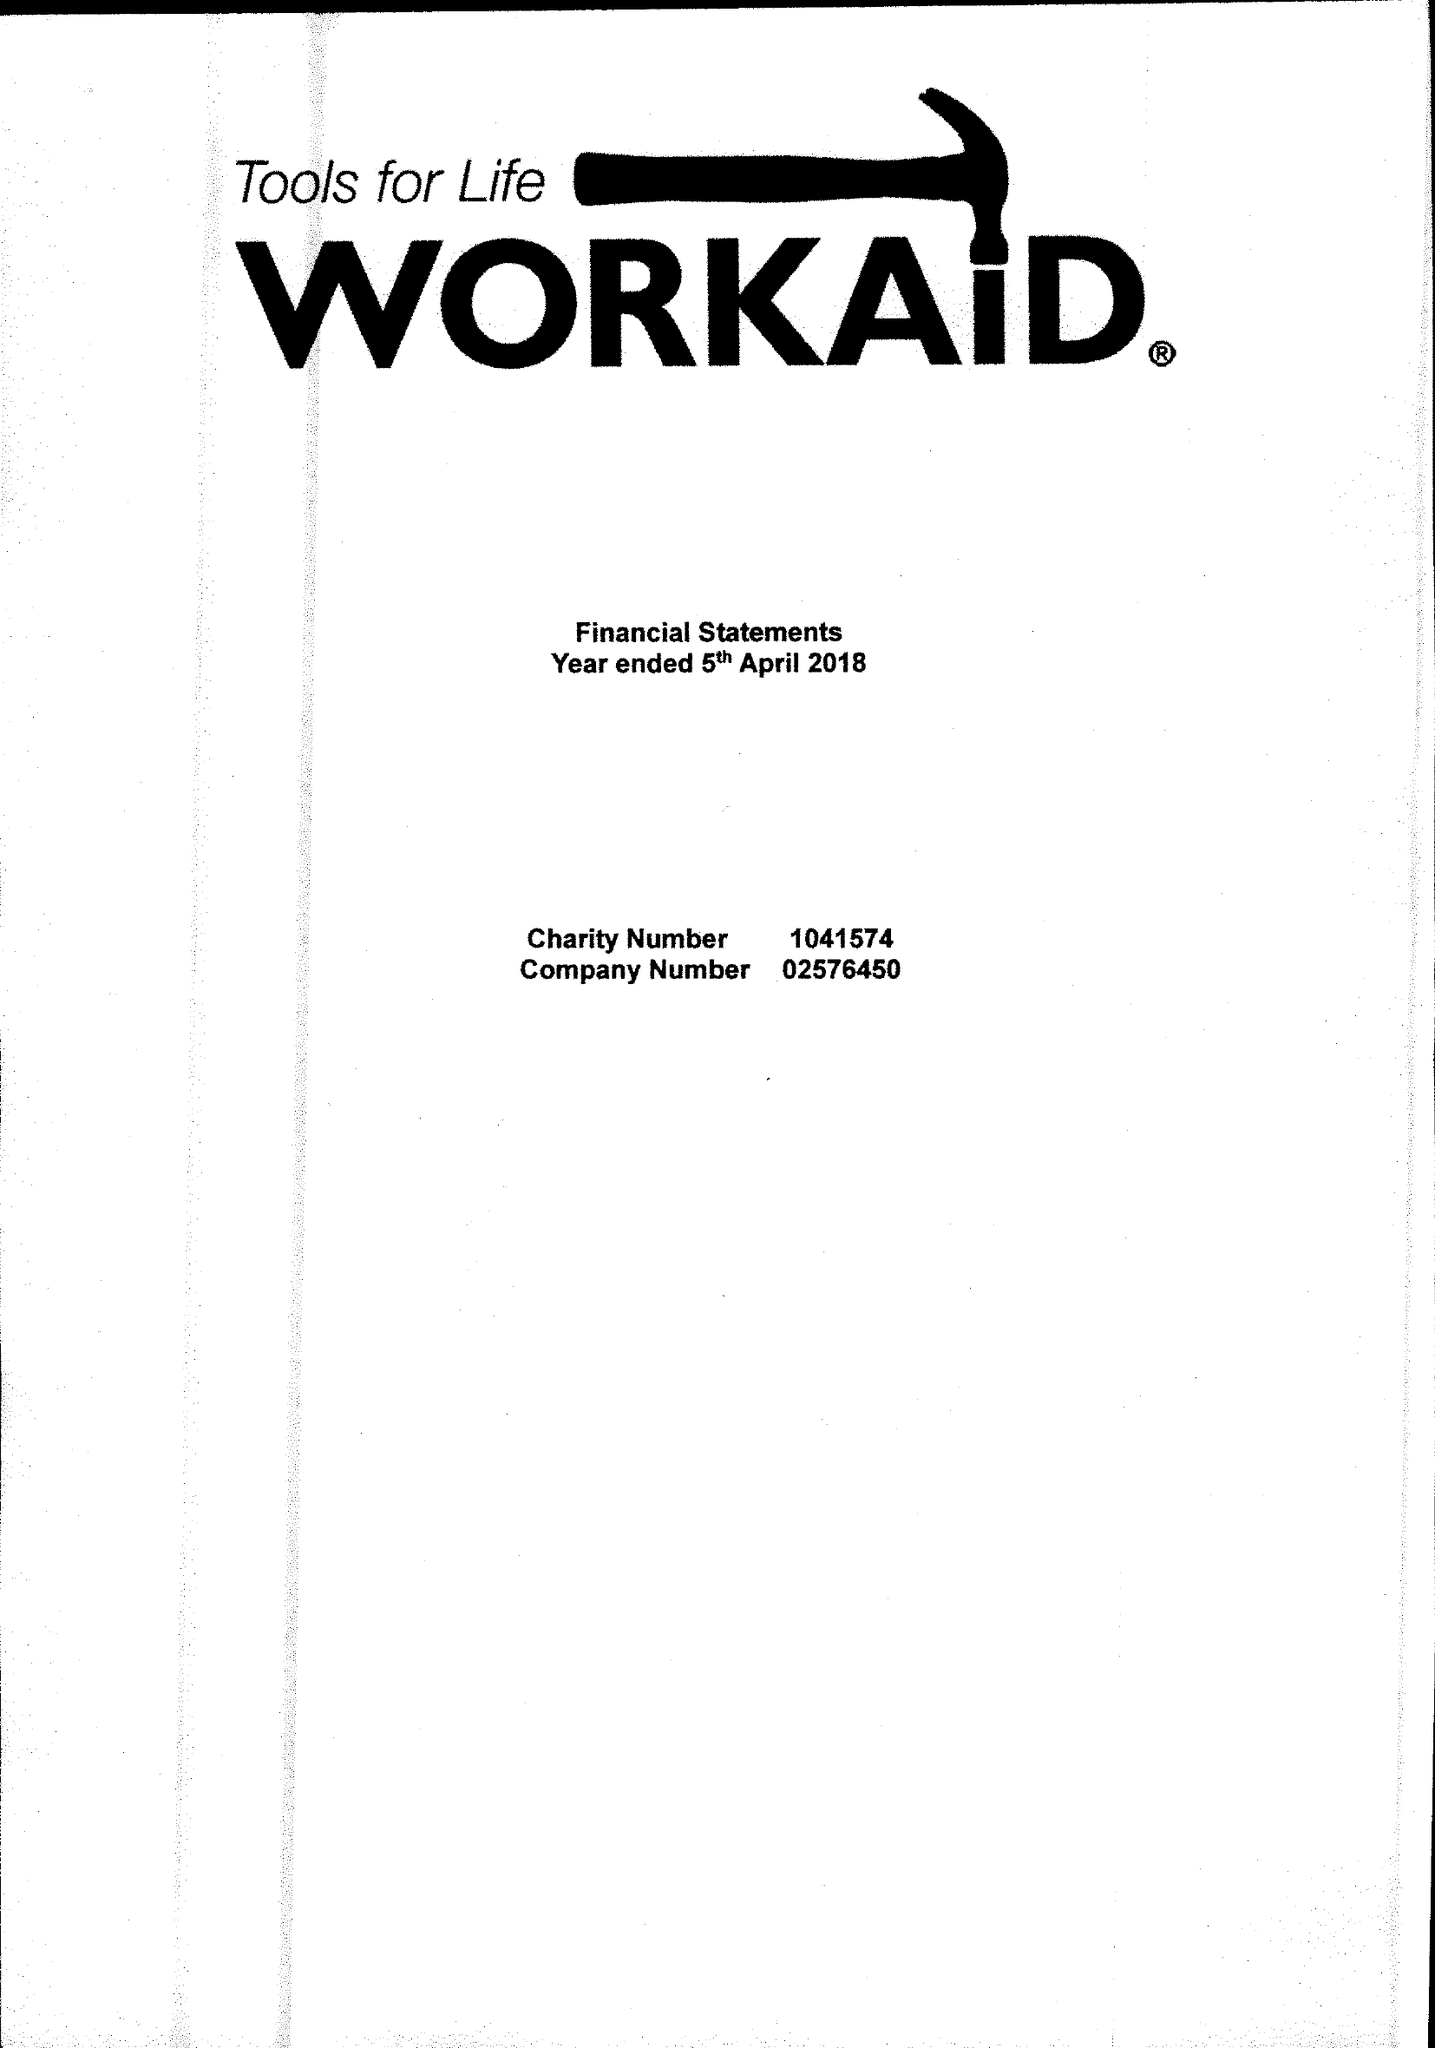What is the value for the address__street_line?
Answer the question using a single word or phrase. 71 TOWNSEND ROAD 